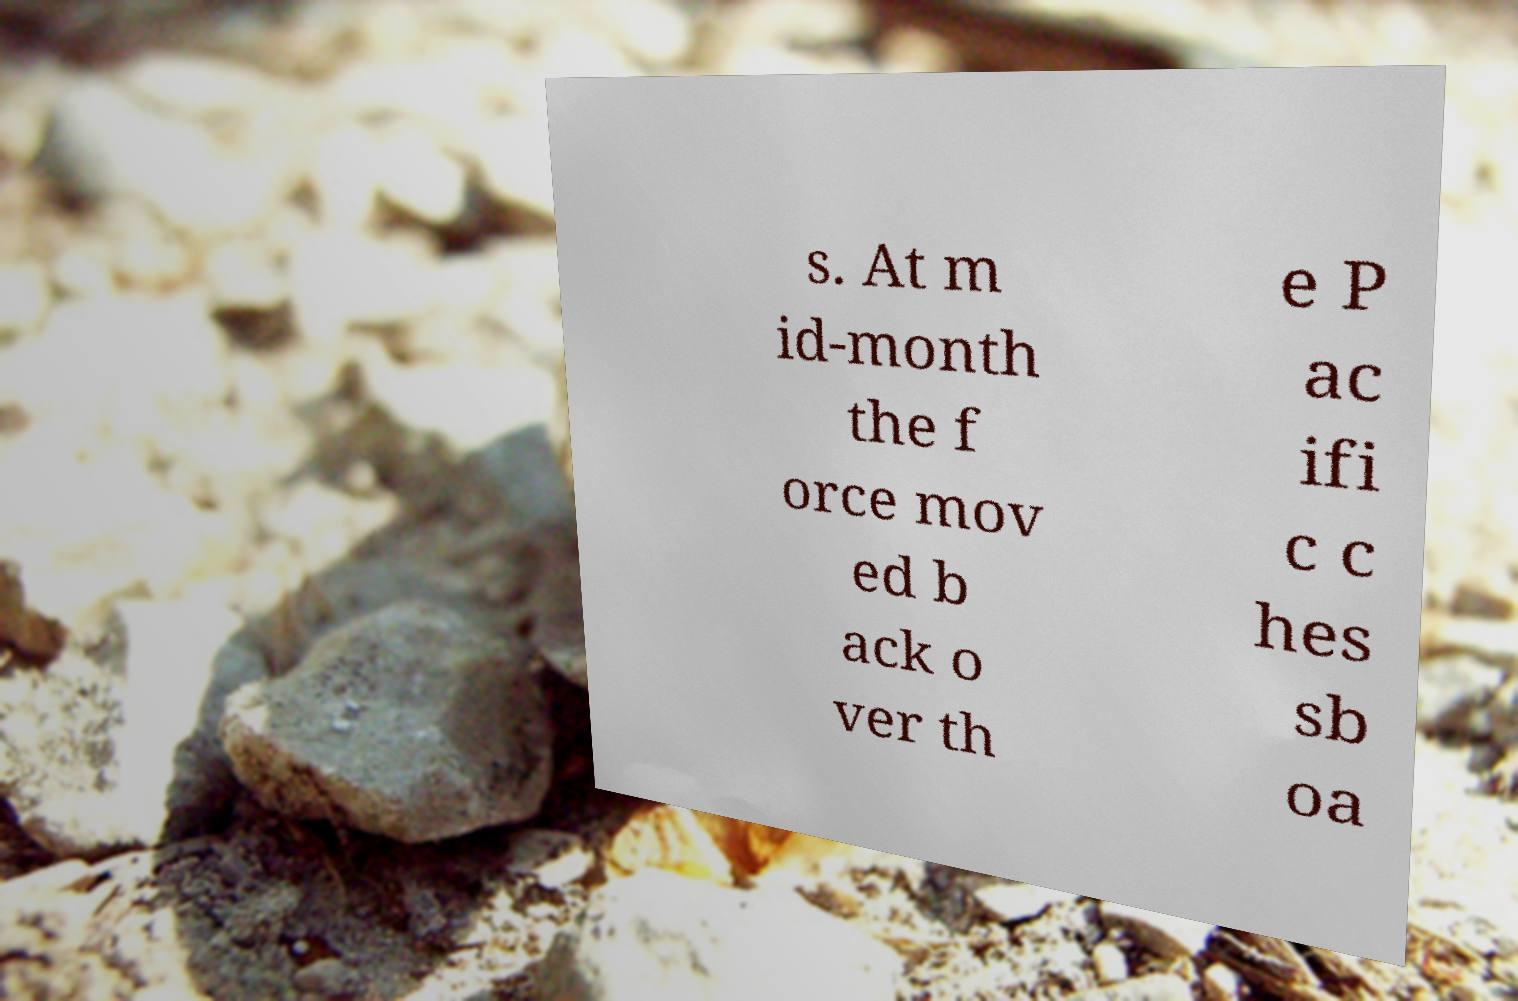Please identify and transcribe the text found in this image. s. At m id-month the f orce mov ed b ack o ver th e P ac ifi c c hes sb oa 